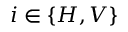<formula> <loc_0><loc_0><loc_500><loc_500>i \in \{ H , V \}</formula> 